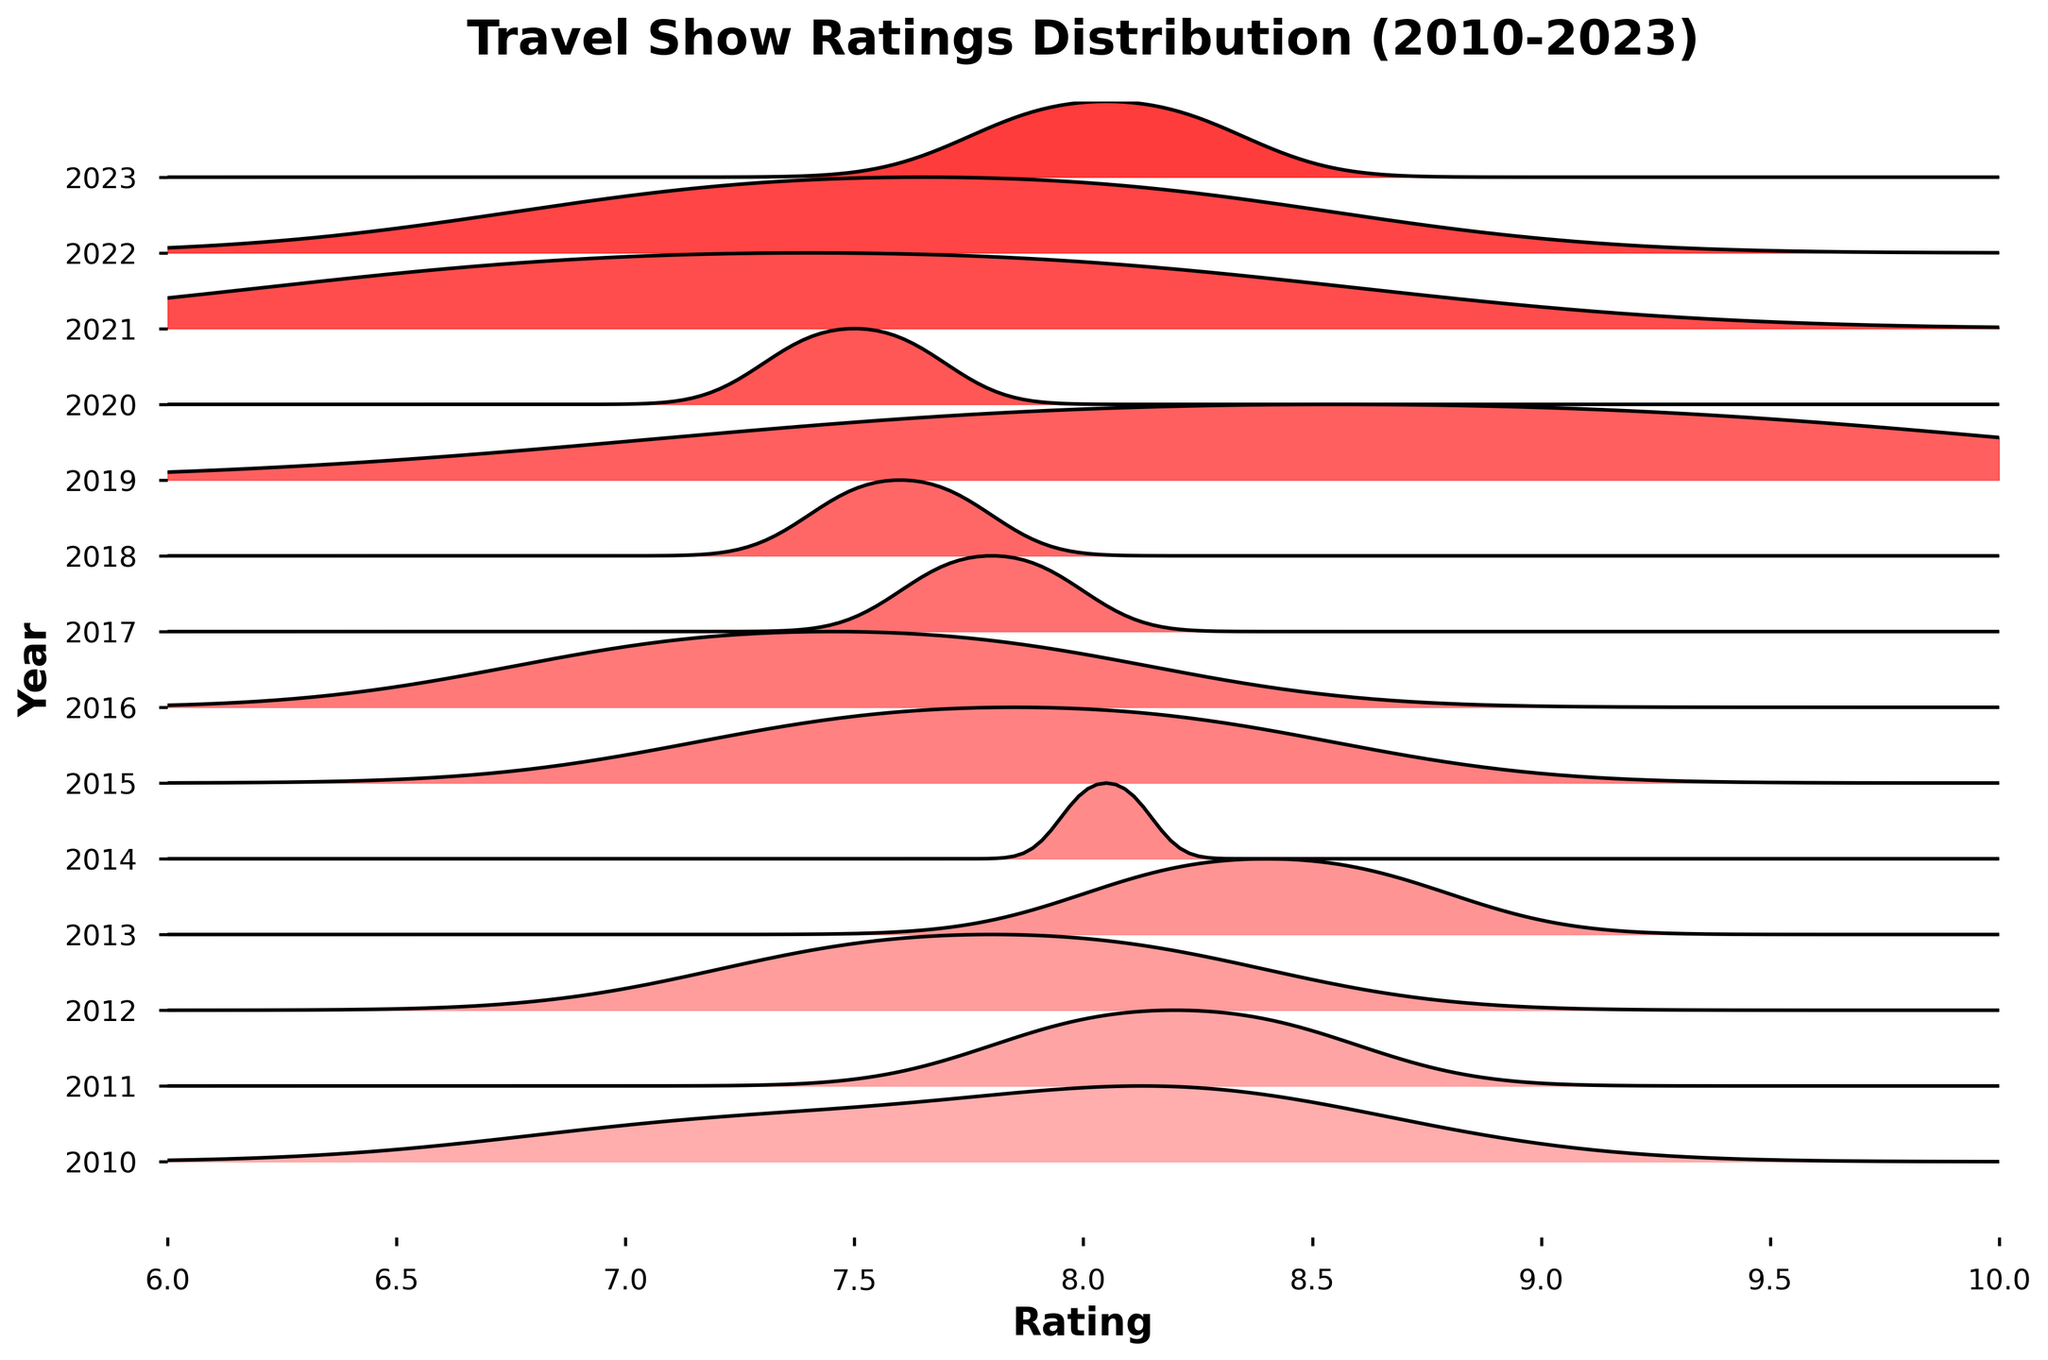What is the title of the figure? The title of the figure is displayed prominently at the top and reads "Travel Show Ratings Distribution (2010-2023)."
Answer: Travel Show Ratings Distribution (2010-2023) Which year has the highest rated travel show in the figure? From the y-axis, you look for the year with the highest peak on the x-axis scale. The year 2019 has the highest peak, indicating "Our Planet" with a rating of 9.3.
Answer: 2019 What is the range of the x-axis? The x-axis represents the "Rating" and ranges from 6 to 10, which is visible by looking at the scale labels on the x-axis.
Answer: 6 to 10 How many years of data are represented in the plot? The number of years can be identified by counting the unique year labels on the y-axis. The labels range from 2010 to 2023, inclusive.
Answer: 14 In which year did travel shows have the most varied ratings? The year with the widest spread on the x-axis indicates the most varied ratings. By observing the widths of the distributions, it appears that 2010 has a broad spread from approximately 7.2 to 8.3.
Answer: 2010 Which year has the narrowest spread of ratings? The narrowest spread can be identified by looking for the year where the distribution is the most compact on the x-axis. The plot for 2021 shows a very compact spread around 6.8 to 8.0.
Answer: 2021 How does the rating peak for 2013 compare to 2015? To compare, observe the highest peaks in both 2013 and 2015. 2013 has a higher peak with a rating around 8.6 (Parts Unknown) compared to 2015, which peaks around 8.2 (An Idiot Abroad).
Answer: 2013 is higher Which year's distribution seems to indicate a consistent average rating, with little fluctuation? A consistent average rating with little fluctuation can be seen in a year with a single prominent peak and minimal spread. 2019 shows a narrow peak indicating high consistency around a single rating (Our Planet, 9.3).
Answer: 2019 Are there any years where the peak rating falls below 7? By scanning the entire x-axis range for each year, none of the distributions peak below a rating of 7.
Answer: No What is the mid-point rating in the 2018 distribution? To find the mid-point, locate the center of the 2018 distribution curve on the x-axis. The mid-point appears to hover around the rating of 7.6.
Answer: 7.6 